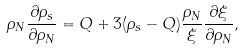Convert formula to latex. <formula><loc_0><loc_0><loc_500><loc_500>\rho _ { N } \frac { \partial \rho _ { s } } { \partial \rho _ { N } } = Q + 3 ( \rho _ { s } - Q ) \frac { \rho _ { N } } \xi \frac { \partial \xi } { \partial \rho _ { N } } ,</formula> 